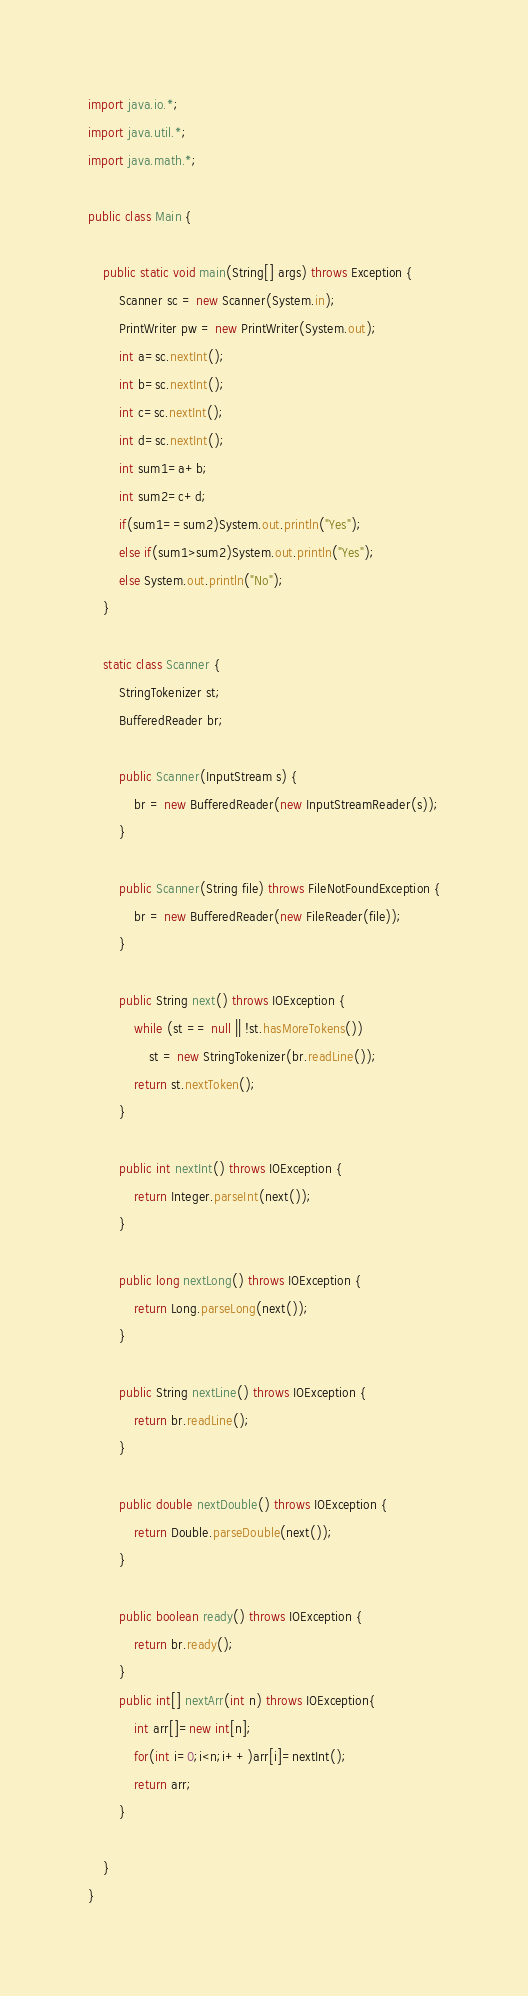Convert code to text. <code><loc_0><loc_0><loc_500><loc_500><_Java_>import java.io.*;
import java.util.*;
import java.math.*;

public class Main {

	public static void main(String[] args) throws Exception {
		Scanner sc = new Scanner(System.in);
		PrintWriter pw = new PrintWriter(System.out);
		int a=sc.nextInt();
		int b=sc.nextInt();
		int c=sc.nextInt();
		int d=sc.nextInt();
		int sum1=a+b;
		int sum2=c+d;
		if(sum1==sum2)System.out.println("Yes");
		else if(sum1>sum2)System.out.println("Yes");
		else System.out.println("No");
	}

	static class Scanner {
		StringTokenizer st;
		BufferedReader br;

		public Scanner(InputStream s) {
			br = new BufferedReader(new InputStreamReader(s));
		}

		public Scanner(String file) throws FileNotFoundException {
			br = new BufferedReader(new FileReader(file));
		}

		public String next() throws IOException {
			while (st == null || !st.hasMoreTokens())
				st = new StringTokenizer(br.readLine());
			return st.nextToken();
		}

		public int nextInt() throws IOException {
			return Integer.parseInt(next());
		}

		public long nextLong() throws IOException {
			return Long.parseLong(next());
		}

		public String nextLine() throws IOException {
			return br.readLine();
		}

		public double nextDouble() throws IOException {
			return Double.parseDouble(next());
		}

		public boolean ready() throws IOException {
			return br.ready();
		}
		public int[] nextArr(int n) throws IOException{
			int arr[]=new int[n];
			for(int i=0;i<n;i++)arr[i]=nextInt();
			return arr;
		}

	}
}</code> 